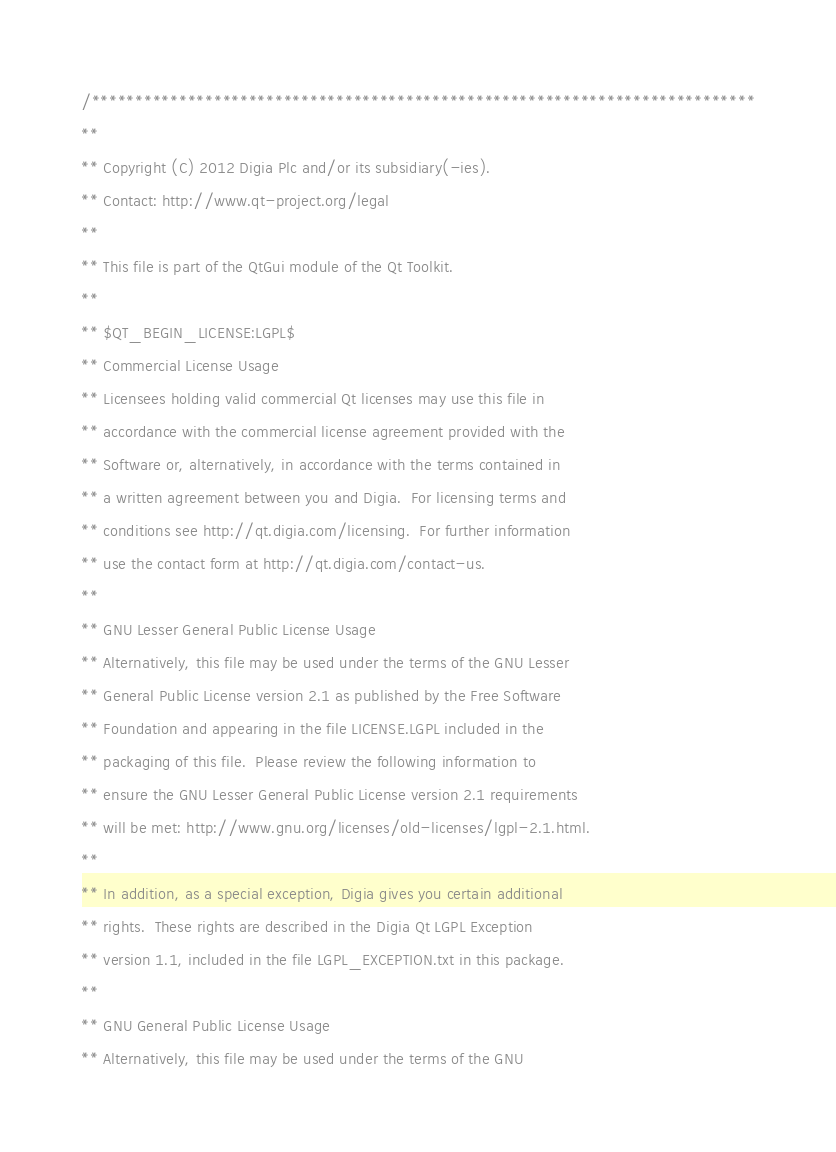Convert code to text. <code><loc_0><loc_0><loc_500><loc_500><_ObjectiveC_>/****************************************************************************
**
** Copyright (C) 2012 Digia Plc and/or its subsidiary(-ies).
** Contact: http://www.qt-project.org/legal
**
** This file is part of the QtGui module of the Qt Toolkit.
**
** $QT_BEGIN_LICENSE:LGPL$
** Commercial License Usage
** Licensees holding valid commercial Qt licenses may use this file in
** accordance with the commercial license agreement provided with the
** Software or, alternatively, in accordance with the terms contained in
** a written agreement between you and Digia.  For licensing terms and
** conditions see http://qt.digia.com/licensing.  For further information
** use the contact form at http://qt.digia.com/contact-us.
**
** GNU Lesser General Public License Usage
** Alternatively, this file may be used under the terms of the GNU Lesser
** General Public License version 2.1 as published by the Free Software
** Foundation and appearing in the file LICENSE.LGPL included in the
** packaging of this file.  Please review the following information to
** ensure the GNU Lesser General Public License version 2.1 requirements
** will be met: http://www.gnu.org/licenses/old-licenses/lgpl-2.1.html.
**
** In addition, as a special exception, Digia gives you certain additional
** rights.  These rights are described in the Digia Qt LGPL Exception
** version 1.1, included in the file LGPL_EXCEPTION.txt in this package.
**
** GNU General Public License Usage
** Alternatively, this file may be used under the terms of the GNU</code> 